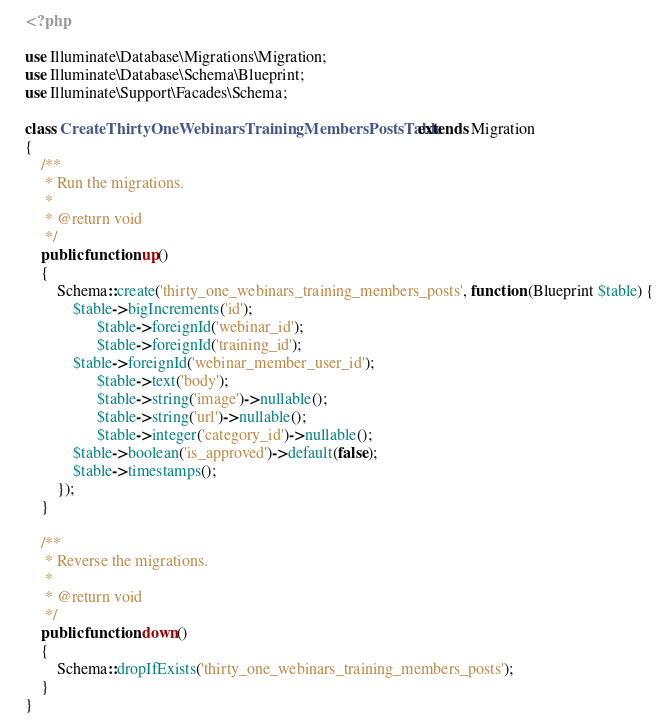Convert code to text. <code><loc_0><loc_0><loc_500><loc_500><_PHP_><?php

use Illuminate\Database\Migrations\Migration;
use Illuminate\Database\Schema\Blueprint;
use Illuminate\Support\Facades\Schema;

class CreateThirtyOneWebinarsTrainingMembersPostsTable extends Migration
{
    /**
     * Run the migrations.
     *
     * @return void
     */
    public function up()
    {
        Schema::create('thirty_one_webinars_training_members_posts', function (Blueprint $table) {
            $table->bigIncrements('id');
			      $table->foreignId('webinar_id');
			      $table->foreignId('training_id');
            $table->foreignId('webinar_member_user_id');
			      $table->text('body');
			      $table->string('image')->nullable();
			      $table->string('url')->nullable();
			      $table->integer('category_id')->nullable();
            $table->boolean('is_approved')->default(false);
            $table->timestamps();
        });
    }

    /**
     * Reverse the migrations.
     *
     * @return void
     */
    public function down()
    {
        Schema::dropIfExists('thirty_one_webinars_training_members_posts');
    }
}
</code> 